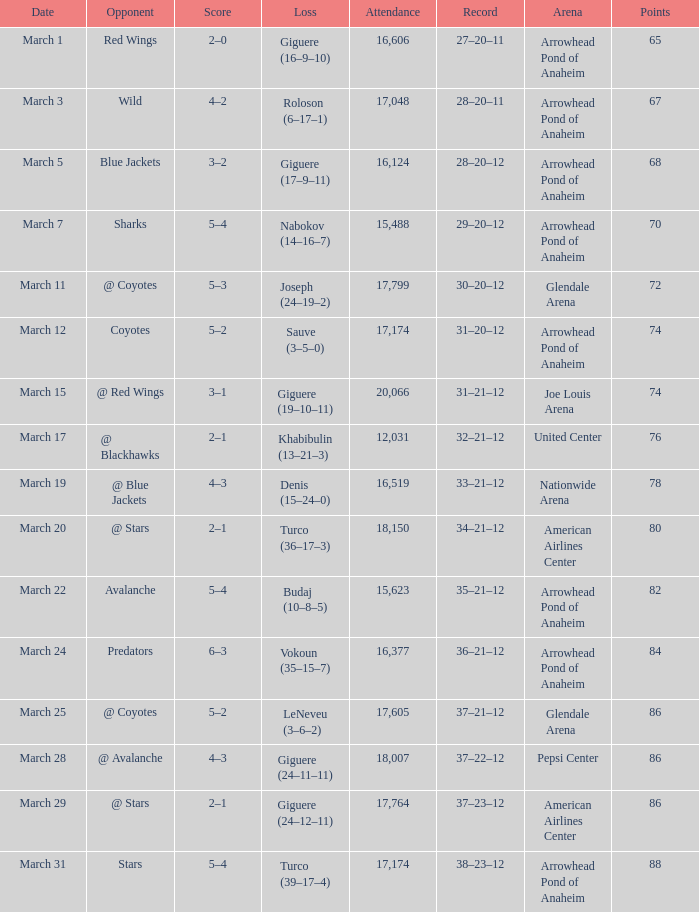Could you parse the entire table? {'header': ['Date', 'Opponent', 'Score', 'Loss', 'Attendance', 'Record', 'Arena', 'Points'], 'rows': [['March 1', 'Red Wings', '2–0', 'Giguere (16–9–10)', '16,606', '27–20–11', 'Arrowhead Pond of Anaheim', '65'], ['March 3', 'Wild', '4–2', 'Roloson (6–17–1)', '17,048', '28–20–11', 'Arrowhead Pond of Anaheim', '67'], ['March 5', 'Blue Jackets', '3–2', 'Giguere (17–9–11)', '16,124', '28–20–12', 'Arrowhead Pond of Anaheim', '68'], ['March 7', 'Sharks', '5–4', 'Nabokov (14–16–7)', '15,488', '29–20–12', 'Arrowhead Pond of Anaheim', '70'], ['March 11', '@ Coyotes', '5–3', 'Joseph (24–19–2)', '17,799', '30–20–12', 'Glendale Arena', '72'], ['March 12', 'Coyotes', '5–2', 'Sauve (3–5–0)', '17,174', '31–20–12', 'Arrowhead Pond of Anaheim', '74'], ['March 15', '@ Red Wings', '3–1', 'Giguere (19–10–11)', '20,066', '31–21–12', 'Joe Louis Arena', '74'], ['March 17', '@ Blackhawks', '2–1', 'Khabibulin (13–21–3)', '12,031', '32–21–12', 'United Center', '76'], ['March 19', '@ Blue Jackets', '4–3', 'Denis (15–24–0)', '16,519', '33–21–12', 'Nationwide Arena', '78'], ['March 20', '@ Stars', '2–1', 'Turco (36–17–3)', '18,150', '34–21–12', 'American Airlines Center', '80'], ['March 22', 'Avalanche', '5–4', 'Budaj (10–8–5)', '15,623', '35–21–12', 'Arrowhead Pond of Anaheim', '82'], ['March 24', 'Predators', '6–3', 'Vokoun (35–15–7)', '16,377', '36–21–12', 'Arrowhead Pond of Anaheim', '84'], ['March 25', '@ Coyotes', '5–2', 'LeNeveu (3–6–2)', '17,605', '37–21–12', 'Glendale Arena', '86'], ['March 28', '@ Avalanche', '4–3', 'Giguere (24–11–11)', '18,007', '37–22–12', 'Pepsi Center', '86'], ['March 29', '@ Stars', '2–1', 'Giguere (24–12–11)', '17,764', '37–23–12', 'American Airlines Center', '86'], ['March 31', 'Stars', '5–4', 'Turco (39–17–4)', '17,174', '38–23–12', 'Arrowhead Pond of Anaheim', '88']]} What is the Attendance at Joe Louis Arena? 20066.0. 